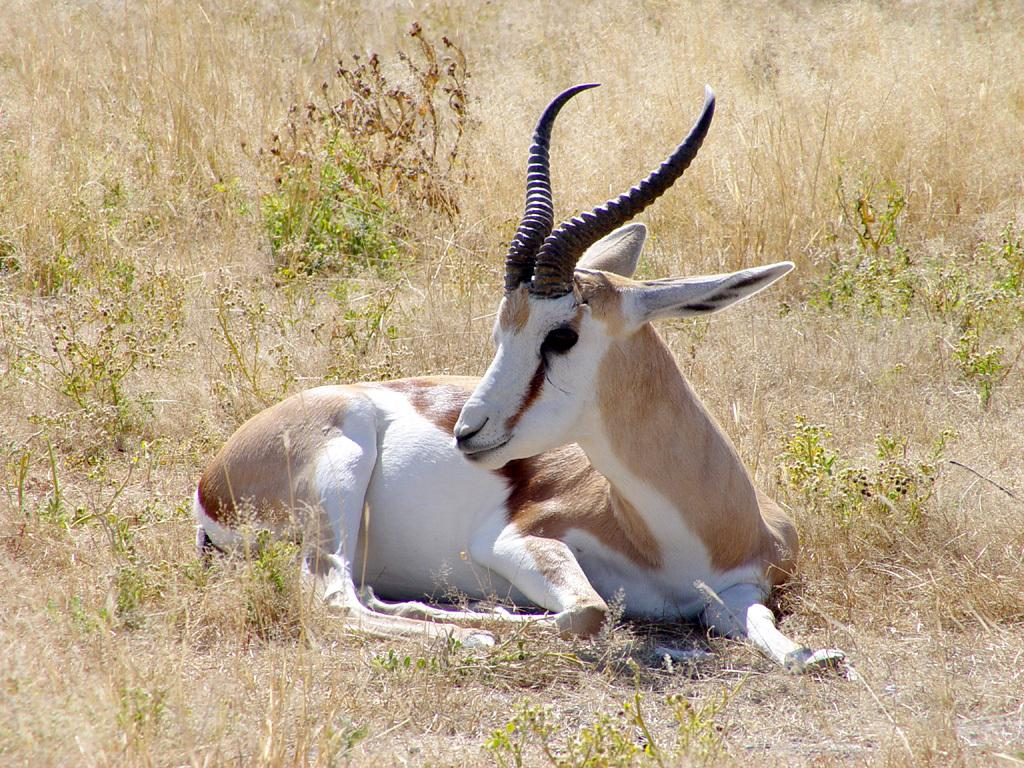What animal is present in the image? There is a goat in the image. What is the goat doing in the image? The goat is sitting on the ground. What type of vegetation can be seen in the image? There are plants and grass in the image. What type of bread is the goat eating in the image? There is no bread present in the image, and the goat is not eating anything. 